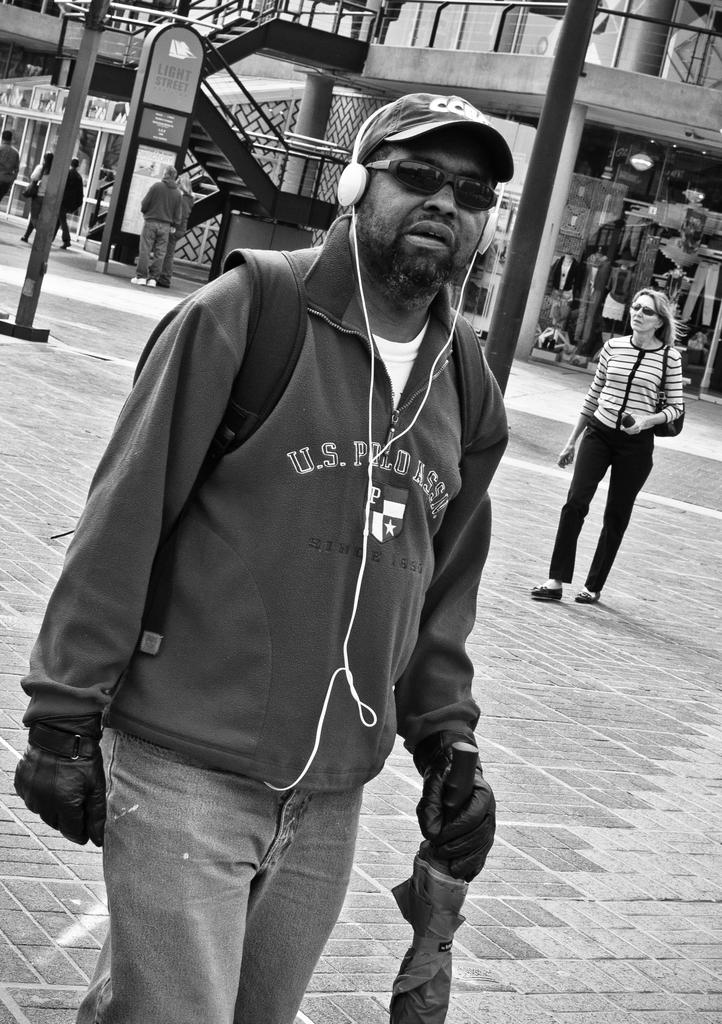What is the color scheme of the image? The image is black and white. What can be seen happening on the road in the image? There are people walking on a road in the image. What is visible in the background of the image? There is a building, steps, and poles in the background of the image. What type of polish is being applied to the steps in the image? There is no indication of any polish being applied in the image; it simply shows people walking on a road and the background elements. 